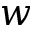<formula> <loc_0><loc_0><loc_500><loc_500>w</formula> 